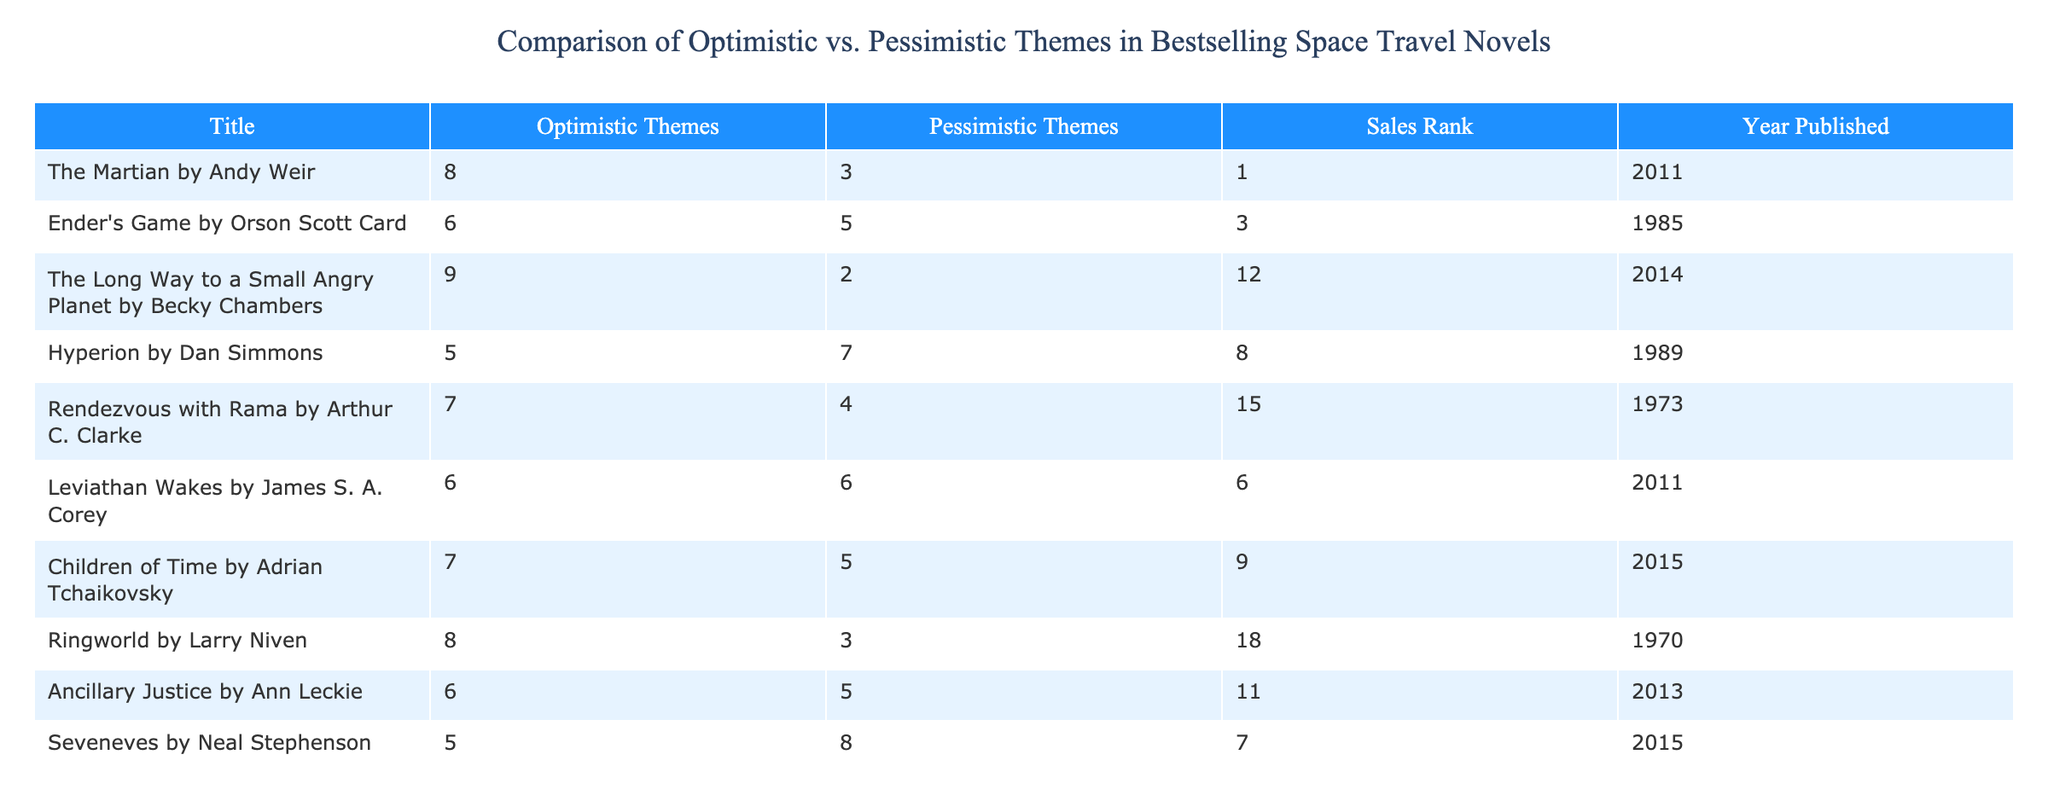What is the sales rank of "The Martian"? In the table, "The Martian" is listed with a Sales Rank of 1.
Answer: 1 Which novel has the highest optimistic themes score? By evaluating the Optimistic Themes column, "The Long Way to a Small Angry Planet" has the highest score of 9.
Answer: "The Long Way to a Small Angry Planet" What is the total number of pessimistic themes across all listed novels? To find the total, we sum the Pessimistic Themes column: 3 + 5 + 2 + 7 + 4 + 6 + 5 + 3 + 5 + 8 = 58.
Answer: 58 Is "Children of Time" more optimistic or pessimistic in its themes? "Children of Time" has 7 optimistic themes and 5 pessimistic themes, indicating it is more optimistic.
Answer: Yes What is the difference in scores between the highest and lowest optimistic themes? The highest optimistic themes score is 9 (from "The Long Way to a Small Angry Planet") and the lowest is 5 (from "Hyperion" and "Seveneves"). The difference is 9 - 5 = 4.
Answer: 4 Which year saw the publication of the novel with the least pessimistic themes? "The Long Way to a Small Angry Planet" was published in 2014 and has the least pessimistic themes score of 2.
Answer: 2014 What is the average score of pessimistic themes for novels published after 2000? The novels published after 2000 are "The Martian", "Leviathan Wakes", "Children of Time", and "The Long Way to a Small Angry Planet". Their pessimistic scores are 3, 6, 5, and 2 respectively, leading to an average of (3 + 6 + 5 + 2)/4 = 4.
Answer: 4 Do any novels share the same score for both themes? Checking the table, "Leviathan Wakes" has a score of 6 for both optimistic and pessimistic themes, thus yes, it shares the same score.
Answer: Yes Which novel has a higher pessimistic themes score, "Ancillary Justice" or "Ringworld"? "Ancillary Justice" has a score of 5 for pessimistic themes while "Ringworld" has a score of 3. Therefore, "Ancillary Justice" has a higher score.
Answer: "Ancillary Justice" 